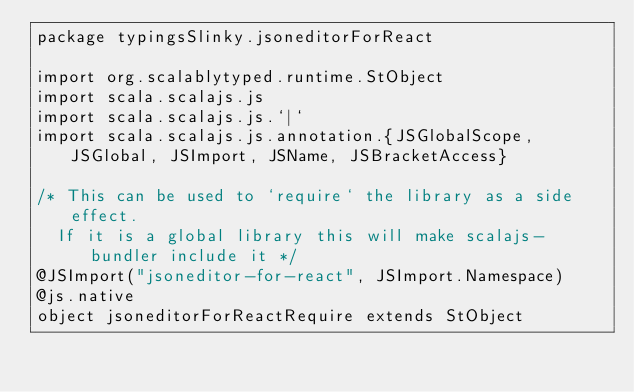<code> <loc_0><loc_0><loc_500><loc_500><_Scala_>package typingsSlinky.jsoneditorForReact

import org.scalablytyped.runtime.StObject
import scala.scalajs.js
import scala.scalajs.js.`|`
import scala.scalajs.js.annotation.{JSGlobalScope, JSGlobal, JSImport, JSName, JSBracketAccess}

/* This can be used to `require` the library as a side effect.
  If it is a global library this will make scalajs-bundler include it */
@JSImport("jsoneditor-for-react", JSImport.Namespace)
@js.native
object jsoneditorForReactRequire extends StObject
</code> 